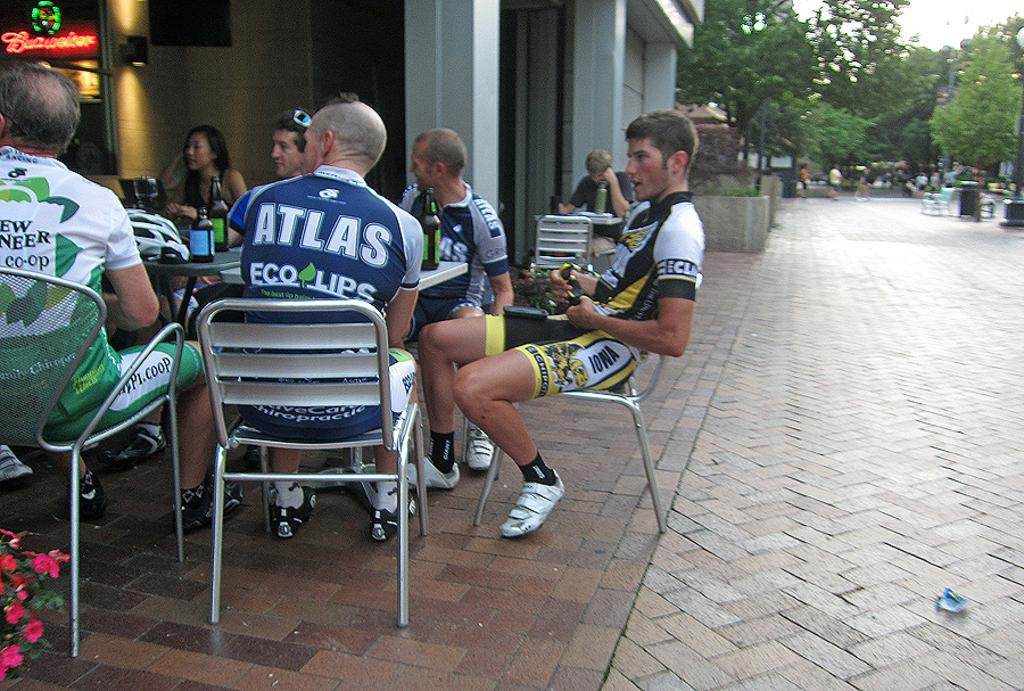Where was the image taken? The image is taken outdoors. What are the people in the image doing? The people are sitting on chairs. What furniture is present in the image? There is a table in the image. What object is on the table? There is a bottle on the table. What can be seen in the background of the image? Trees are visible in the background. What type of bone is visible on the table in the image? There is no bone present on the table in the image. What type of business is being conducted in the image? There is no indication of any business being conducted in the image; it shows people sitting outdoors with a table and a bottle. 